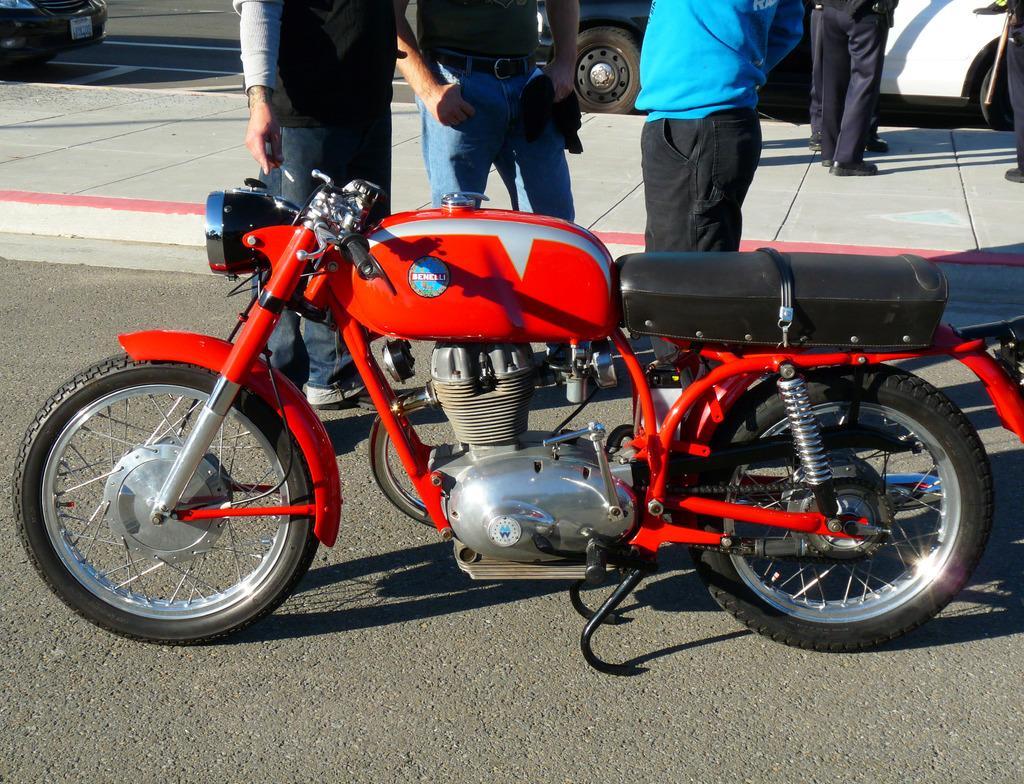Describe this image in one or two sentences. This picture is clicked outside. In the foreground we can see a bike parked on the ground. In the center we can see the group of people standing on the ground and we can see a sidewalk. In the background we can see the vehicles seems to be parked on the ground. 